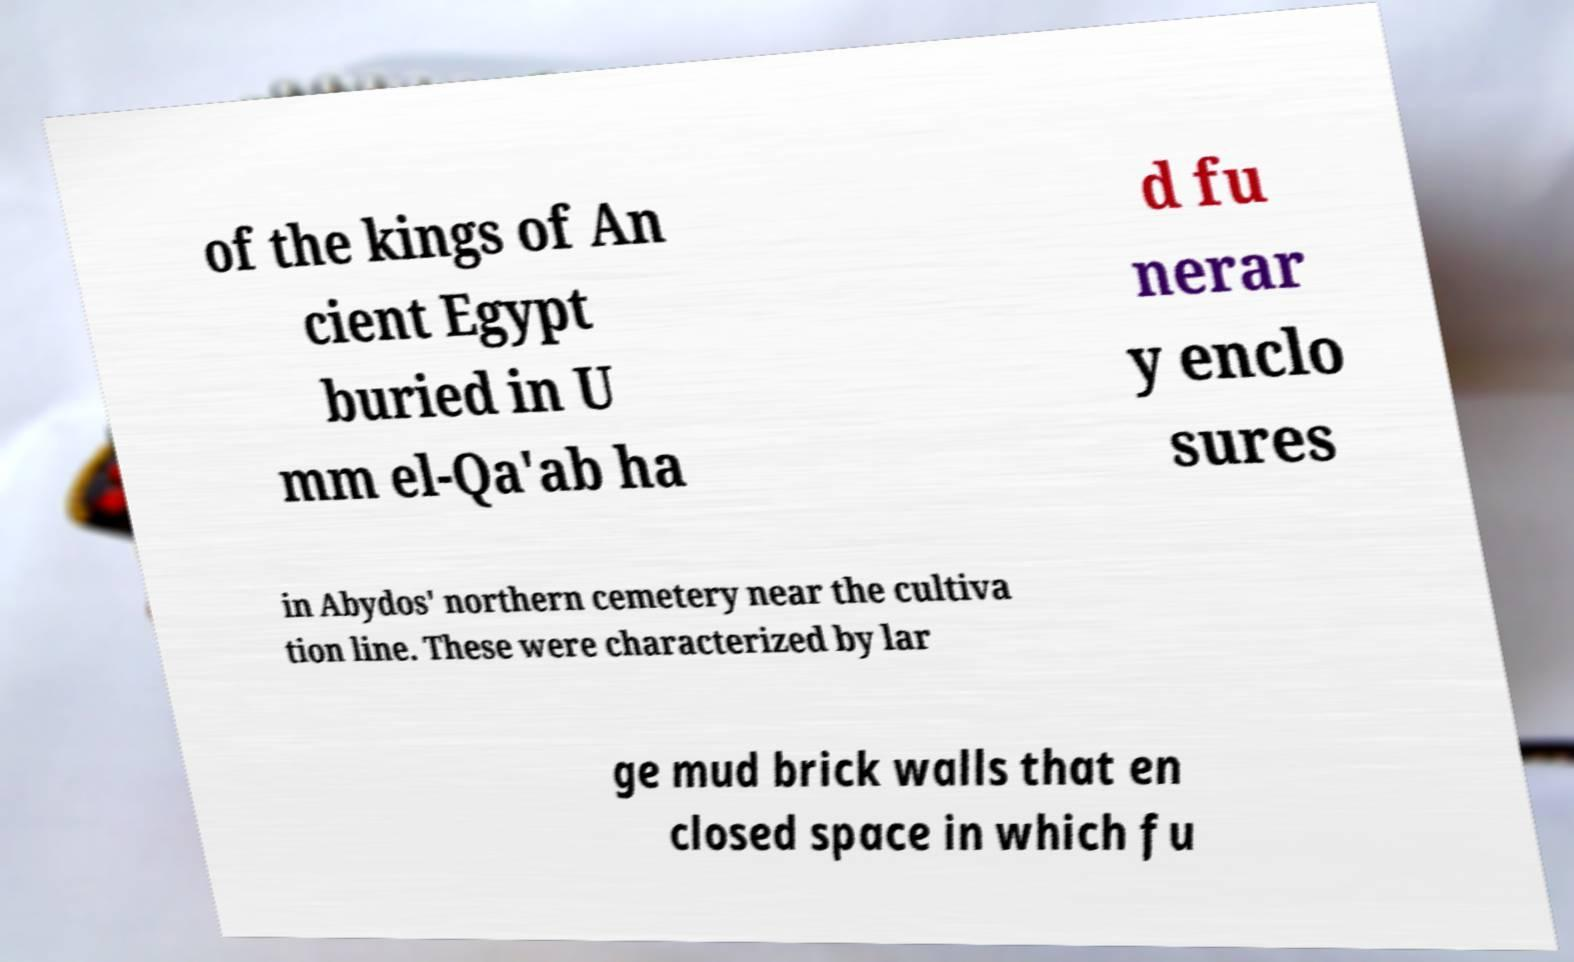Could you extract and type out the text from this image? of the kings of An cient Egypt buried in U mm el-Qa'ab ha d fu nerar y enclo sures in Abydos' northern cemetery near the cultiva tion line. These were characterized by lar ge mud brick walls that en closed space in which fu 